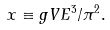Convert formula to latex. <formula><loc_0><loc_0><loc_500><loc_500>x \equiv g V E ^ { 3 } / \pi ^ { 2 } .</formula> 